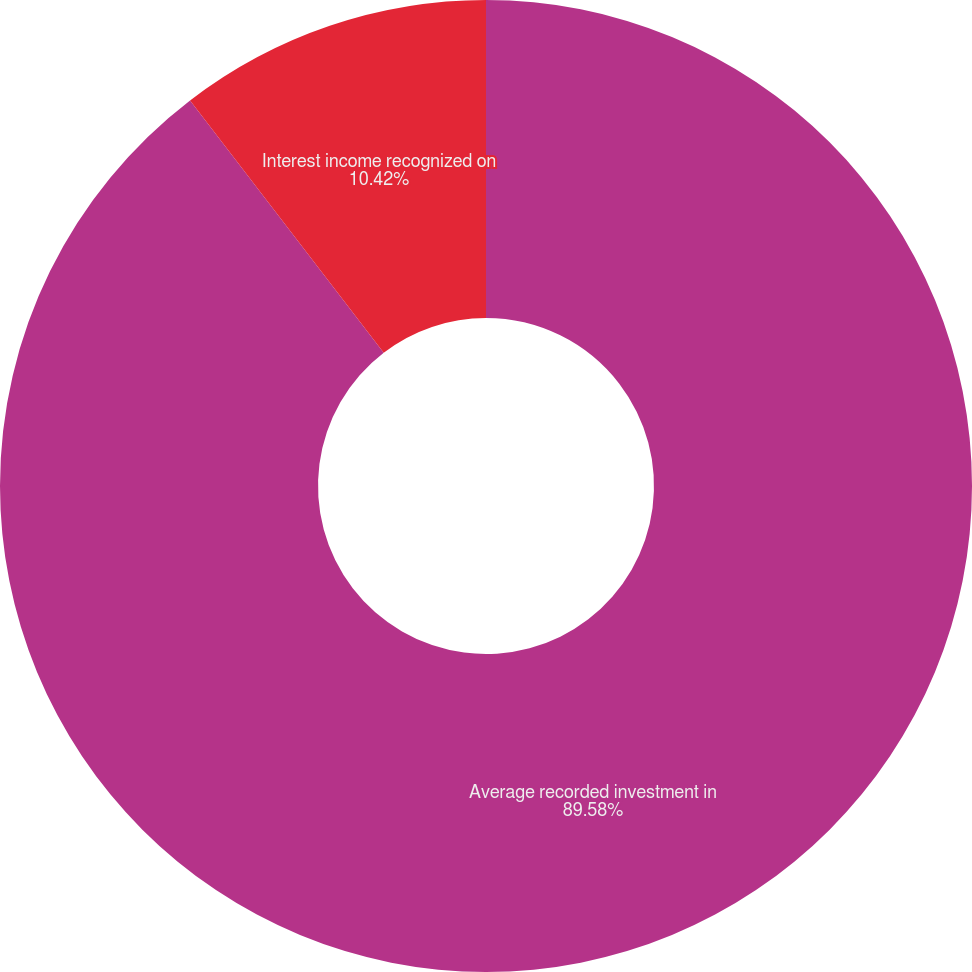Convert chart to OTSL. <chart><loc_0><loc_0><loc_500><loc_500><pie_chart><fcel>Average recorded investment in<fcel>Interest income recognized on<nl><fcel>89.58%<fcel>10.42%<nl></chart> 